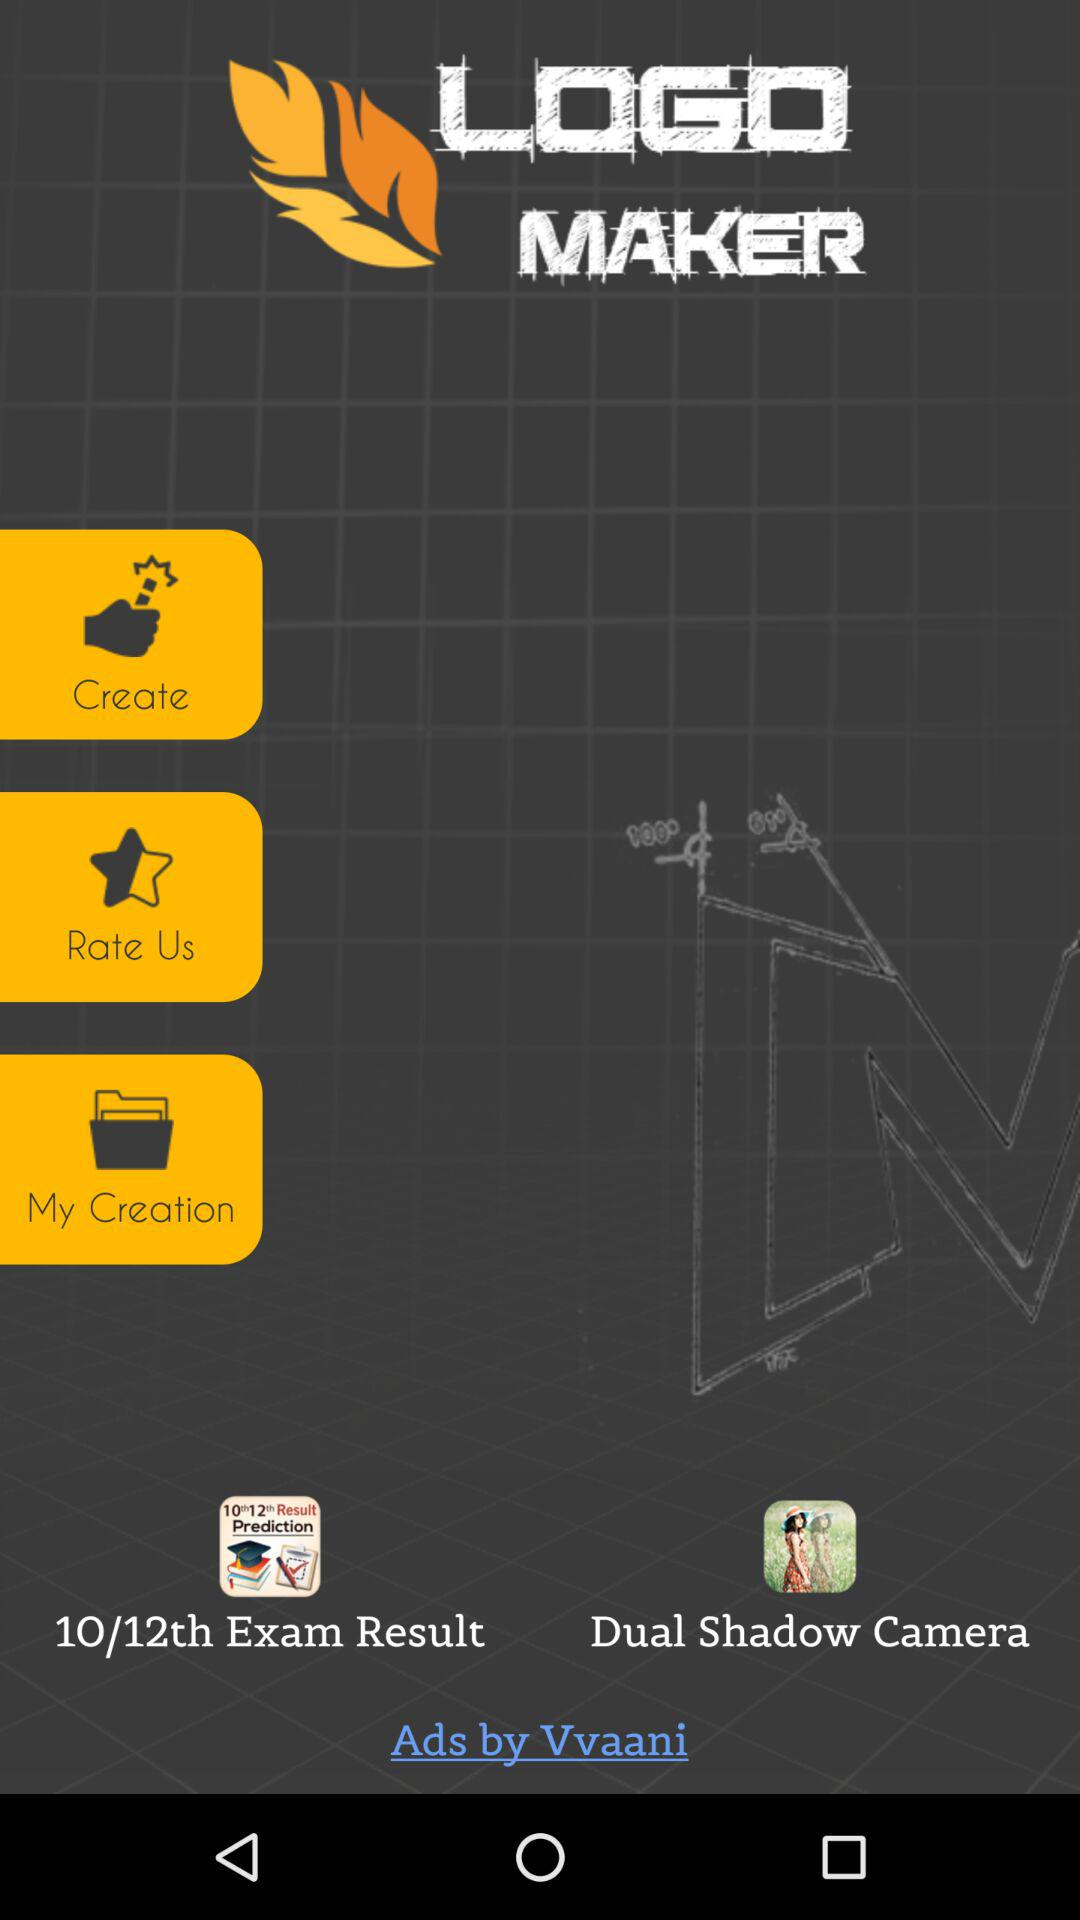How many stars does the application have?
When the provided information is insufficient, respond with <no answer>. <no answer> 